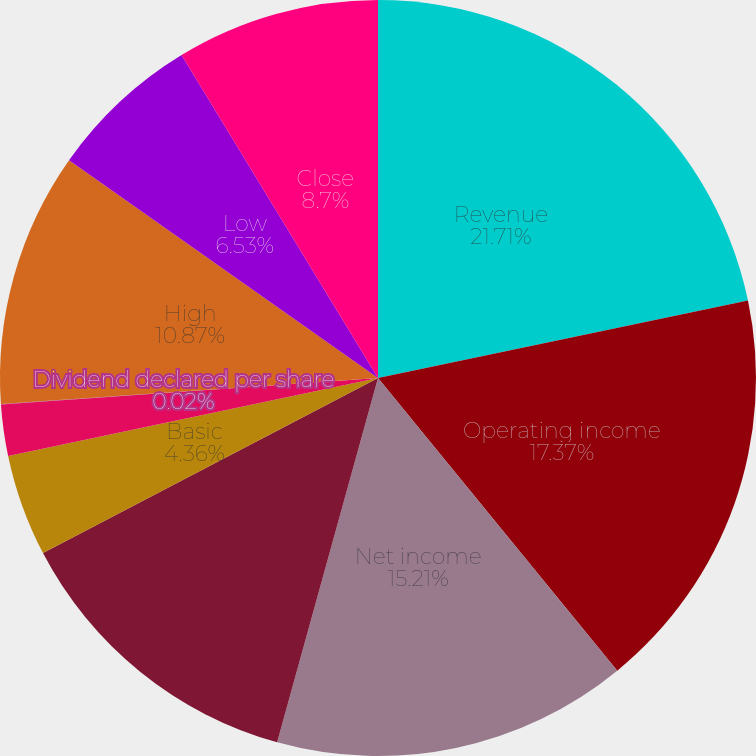Convert chart to OTSL. <chart><loc_0><loc_0><loc_500><loc_500><pie_chart><fcel>Revenue<fcel>Operating income<fcel>Net income<fcel>Net income attributable to<fcel>Basic<fcel>Diluted<fcel>Dividend declared per share<fcel>High<fcel>Low<fcel>Close<nl><fcel>21.72%<fcel>17.38%<fcel>15.21%<fcel>13.04%<fcel>4.36%<fcel>2.19%<fcel>0.02%<fcel>10.87%<fcel>6.53%<fcel>8.7%<nl></chart> 